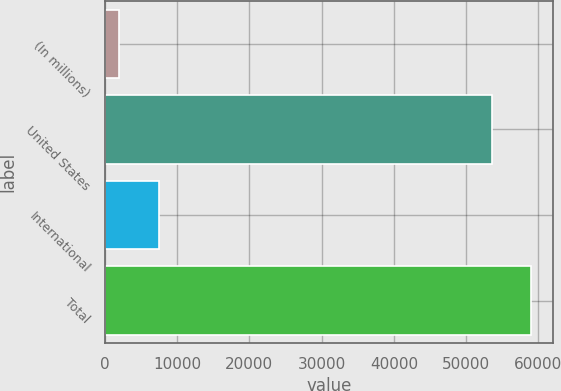<chart> <loc_0><loc_0><loc_500><loc_500><bar_chart><fcel>(In millions)<fcel>United States<fcel>International<fcel>Total<nl><fcel>2003<fcel>53544.8<fcel>7514.78<fcel>59056.6<nl></chart> 